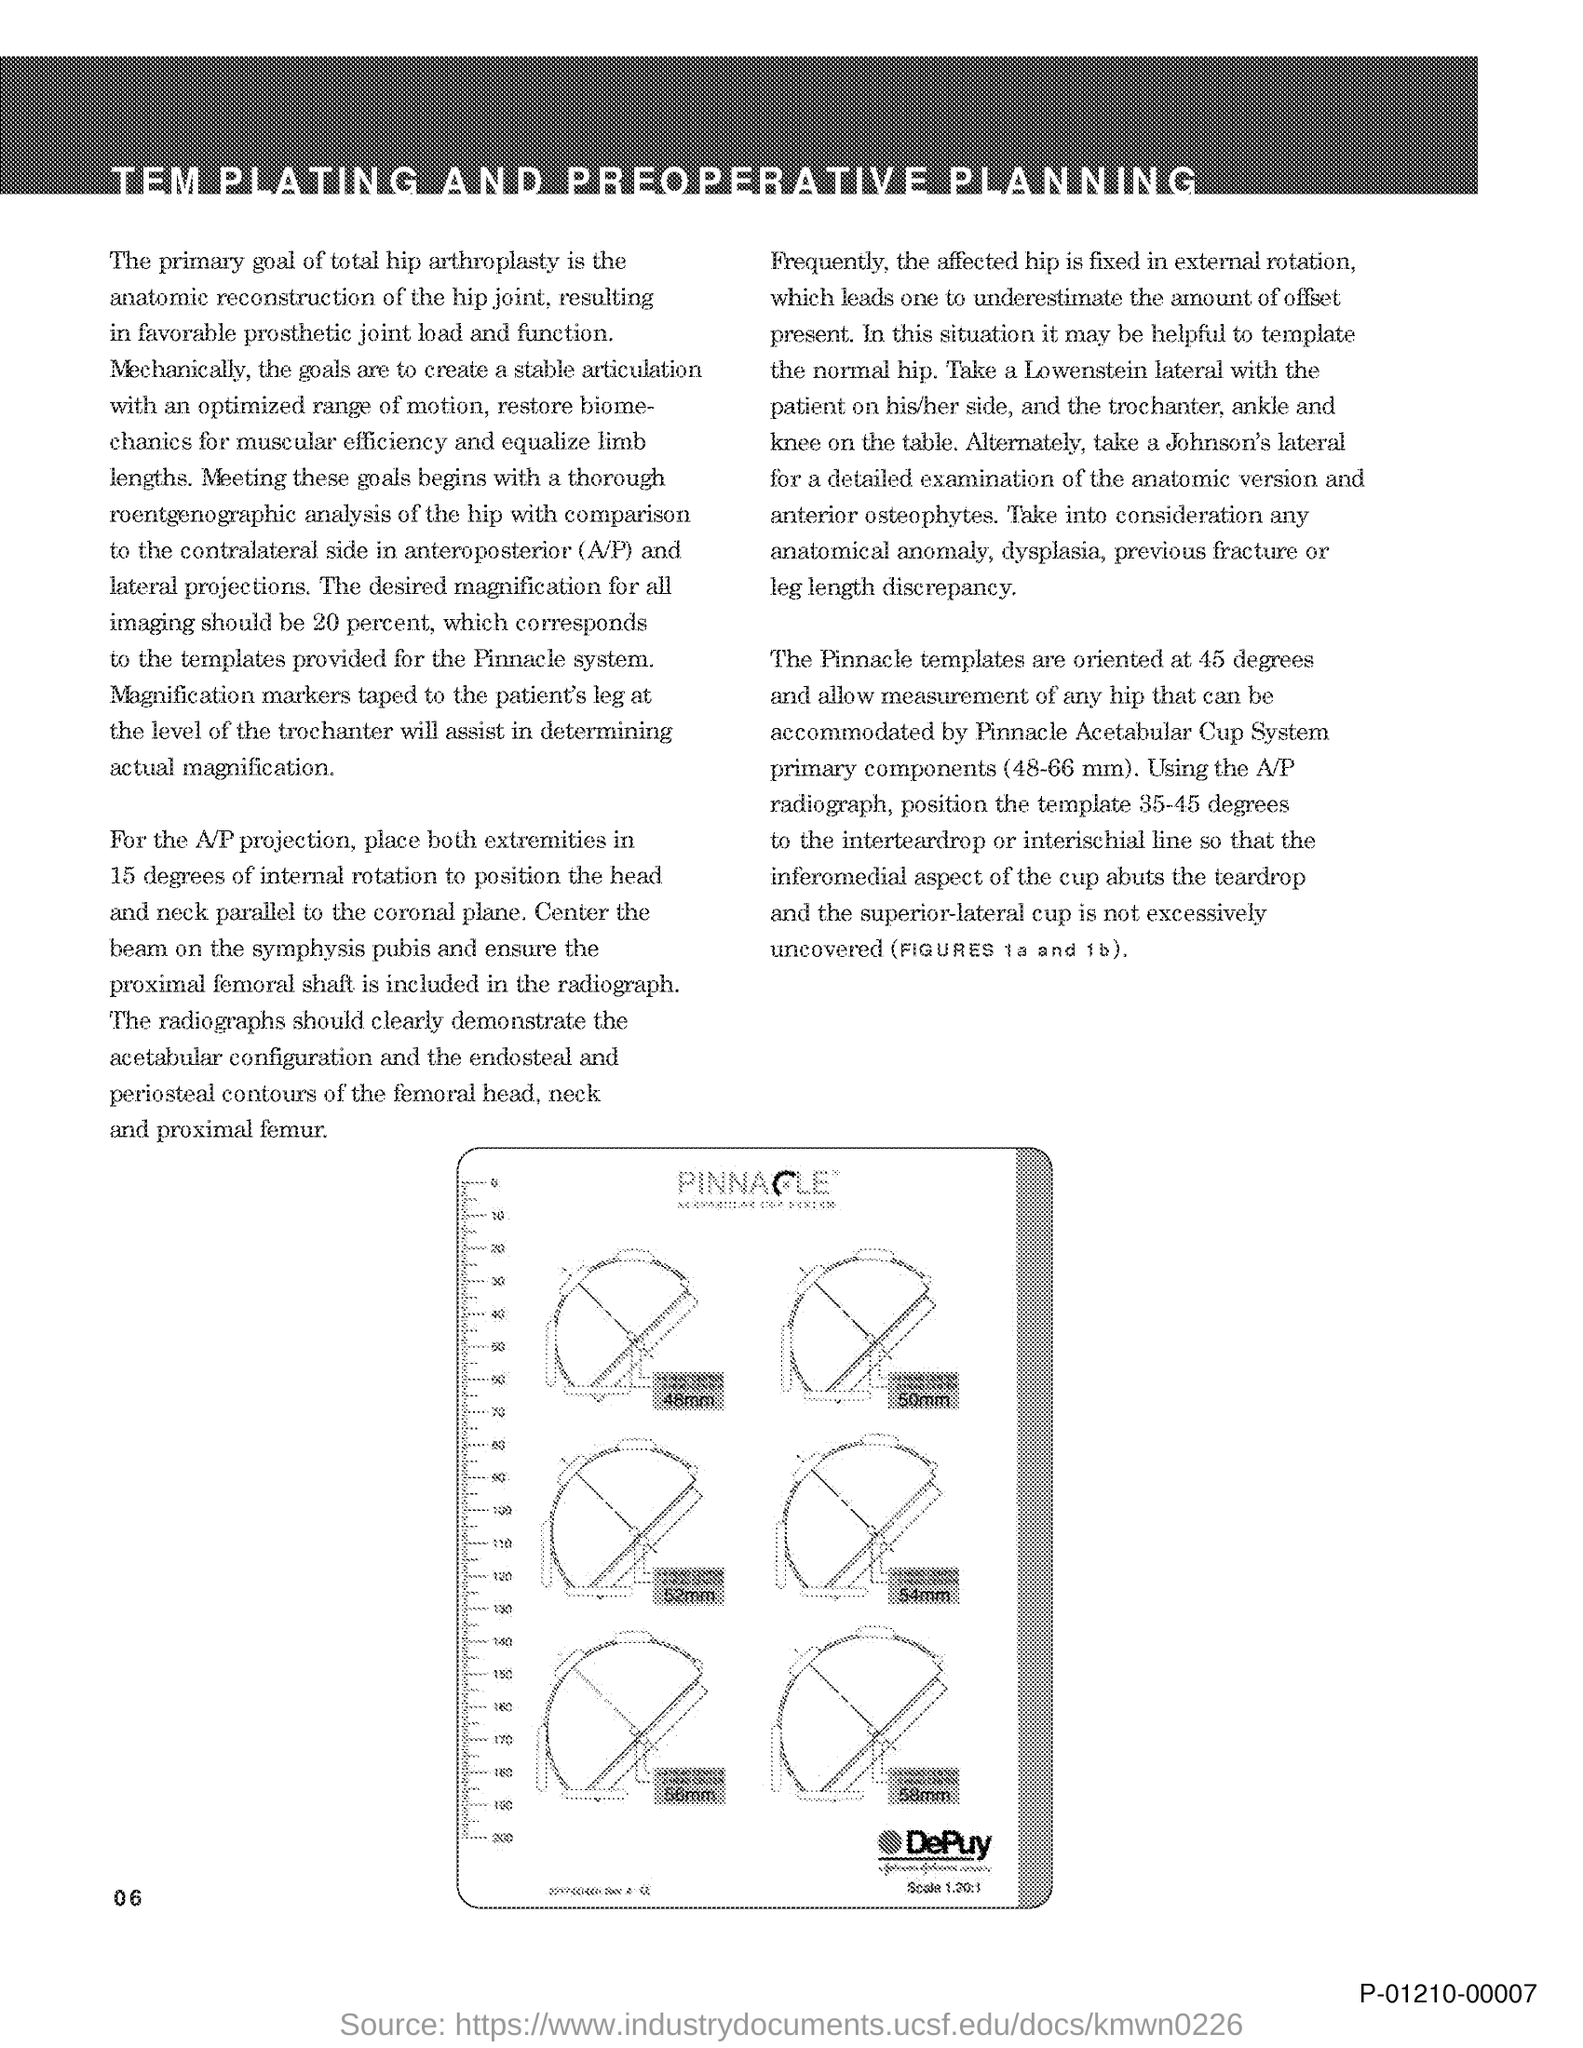The pinnacle templates are oriented at what angle?
Your answer should be very brief. 45 degrees. What is the Page Number?
Make the answer very short. 06. 